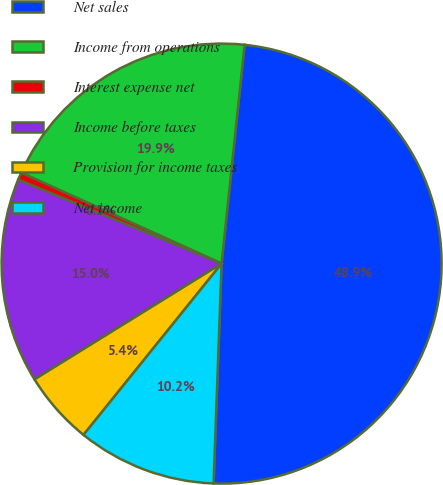Convert chart. <chart><loc_0><loc_0><loc_500><loc_500><pie_chart><fcel>Net sales<fcel>Income from operations<fcel>Interest expense net<fcel>Income before taxes<fcel>Provision for income taxes<fcel>Net income<nl><fcel>48.91%<fcel>19.89%<fcel>0.55%<fcel>15.05%<fcel>5.38%<fcel>10.22%<nl></chart> 